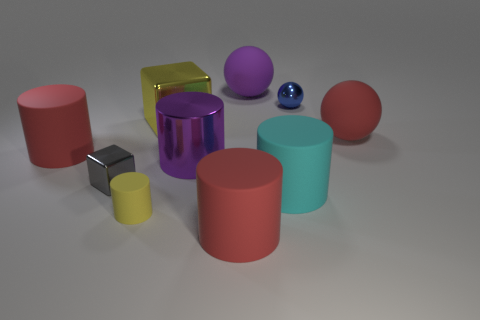Subtract all large spheres. How many spheres are left? 1 Subtract 2 spheres. How many spheres are left? 1 Subtract all red cubes. How many brown cylinders are left? 0 Subtract all tiny green shiny cylinders. Subtract all gray metallic blocks. How many objects are left? 9 Add 2 big metallic things. How many big metallic things are left? 4 Add 6 small metal blocks. How many small metal blocks exist? 7 Subtract all purple balls. How many balls are left? 2 Subtract 0 cyan cubes. How many objects are left? 10 Subtract all blocks. How many objects are left? 8 Subtract all red balls. Subtract all blue cubes. How many balls are left? 2 